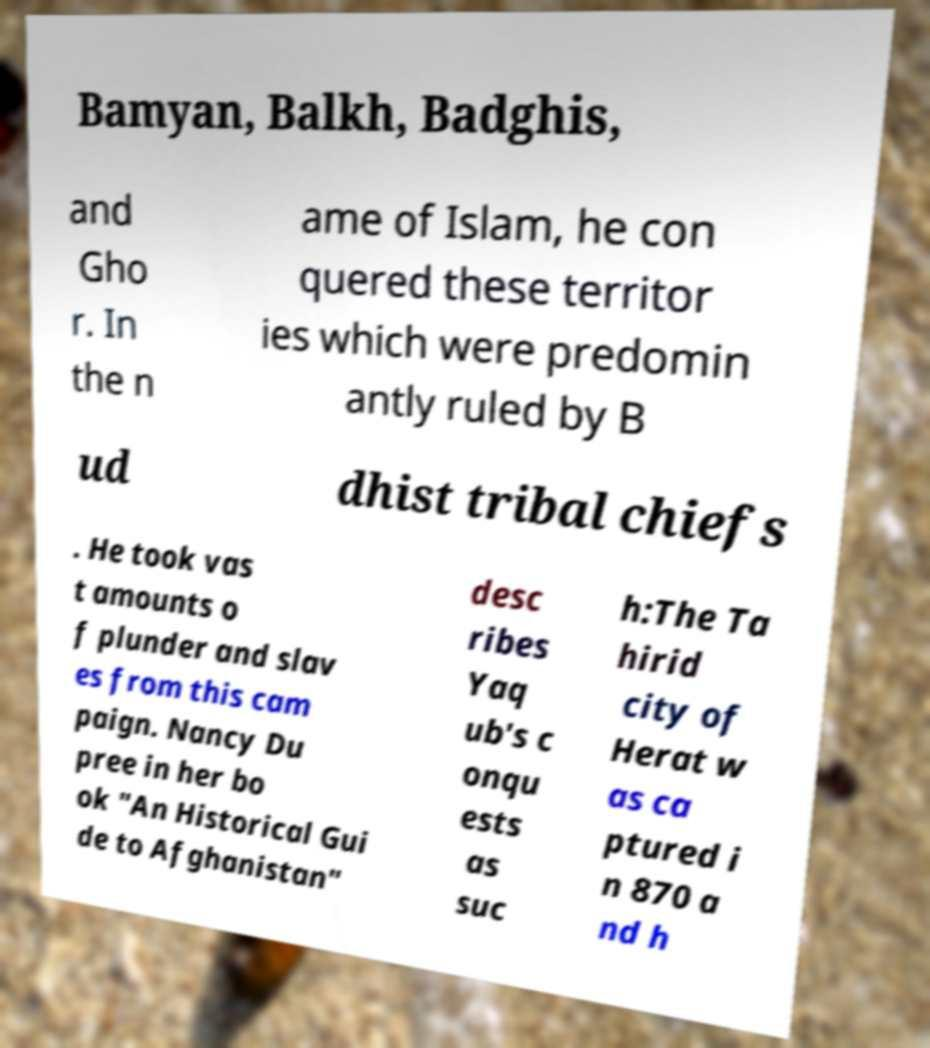What messages or text are displayed in this image? I need them in a readable, typed format. Bamyan, Balkh, Badghis, and Gho r. In the n ame of Islam, he con quered these territor ies which were predomin antly ruled by B ud dhist tribal chiefs . He took vas t amounts o f plunder and slav es from this cam paign. Nancy Du pree in her bo ok "An Historical Gui de to Afghanistan" desc ribes Yaq ub's c onqu ests as suc h:The Ta hirid city of Herat w as ca ptured i n 870 a nd h 